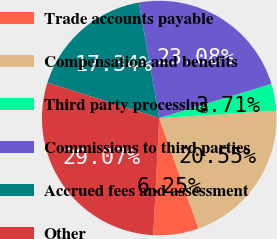Convert chart. <chart><loc_0><loc_0><loc_500><loc_500><pie_chart><fcel>Trade accounts payable<fcel>Compensation and benefits<fcel>Third party processing<fcel>Commissions to third parties<fcel>Accrued fees and assessment<fcel>Other<nl><fcel>6.25%<fcel>20.55%<fcel>3.71%<fcel>23.08%<fcel>17.34%<fcel>29.07%<nl></chart> 